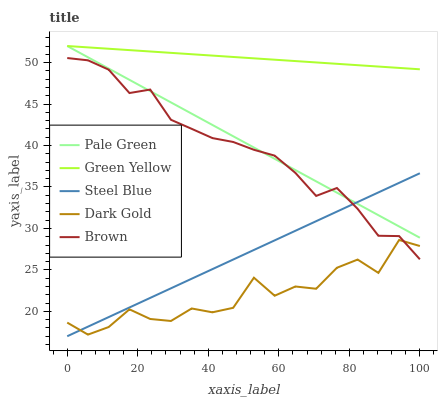Does Dark Gold have the minimum area under the curve?
Answer yes or no. Yes. Does Green Yellow have the maximum area under the curve?
Answer yes or no. Yes. Does Pale Green have the minimum area under the curve?
Answer yes or no. No. Does Pale Green have the maximum area under the curve?
Answer yes or no. No. Is Green Yellow the smoothest?
Answer yes or no. Yes. Is Dark Gold the roughest?
Answer yes or no. Yes. Is Pale Green the smoothest?
Answer yes or no. No. Is Pale Green the roughest?
Answer yes or no. No. Does Steel Blue have the lowest value?
Answer yes or no. Yes. Does Pale Green have the lowest value?
Answer yes or no. No. Does Pale Green have the highest value?
Answer yes or no. Yes. Does Steel Blue have the highest value?
Answer yes or no. No. Is Dark Gold less than Pale Green?
Answer yes or no. Yes. Is Green Yellow greater than Brown?
Answer yes or no. Yes. Does Brown intersect Steel Blue?
Answer yes or no. Yes. Is Brown less than Steel Blue?
Answer yes or no. No. Is Brown greater than Steel Blue?
Answer yes or no. No. Does Dark Gold intersect Pale Green?
Answer yes or no. No. 